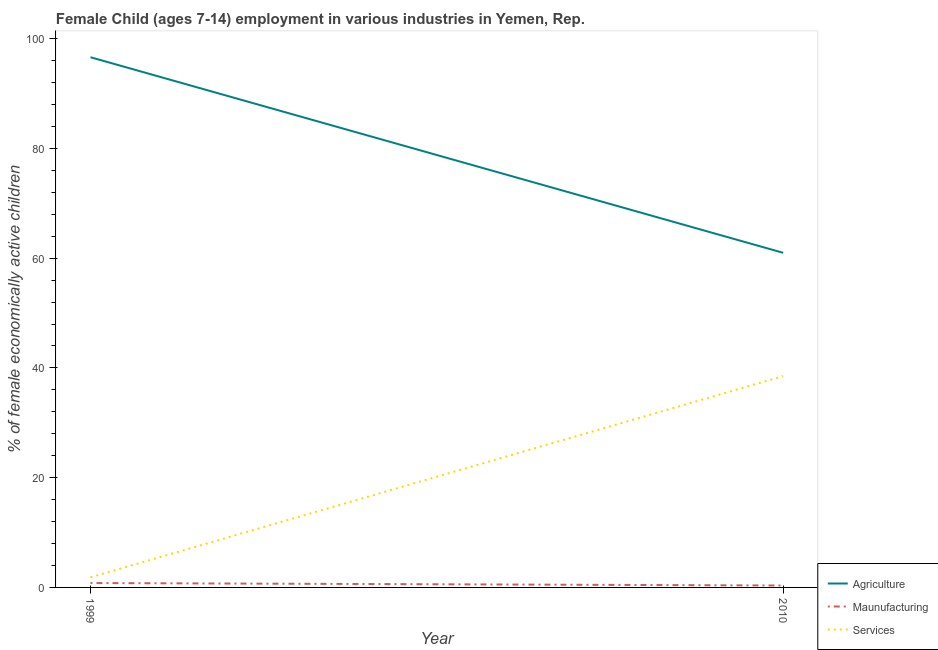How many different coloured lines are there?
Give a very brief answer. 3. What is the percentage of economically active children in agriculture in 2010?
Your answer should be compact. 60.98. Across all years, what is the maximum percentage of economically active children in services?
Provide a short and direct response. 38.51. Across all years, what is the minimum percentage of economically active children in services?
Offer a very short reply. 1.84. In which year was the percentage of economically active children in services maximum?
Offer a terse response. 2010. In which year was the percentage of economically active children in manufacturing minimum?
Your response must be concise. 2010. What is the total percentage of economically active children in services in the graph?
Ensure brevity in your answer.  40.35. What is the difference between the percentage of economically active children in manufacturing in 1999 and that in 2010?
Provide a succinct answer. 0.45. What is the difference between the percentage of economically active children in manufacturing in 2010 and the percentage of economically active children in services in 1999?
Provide a succinct answer. -1.49. What is the average percentage of economically active children in agriculture per year?
Provide a short and direct response. 78.8. In the year 2010, what is the difference between the percentage of economically active children in agriculture and percentage of economically active children in services?
Ensure brevity in your answer.  22.47. What is the ratio of the percentage of economically active children in services in 1999 to that in 2010?
Offer a terse response. 0.05. Is the percentage of economically active children in manufacturing in 1999 less than that in 2010?
Offer a very short reply. No. Is it the case that in every year, the sum of the percentage of economically active children in agriculture and percentage of economically active children in manufacturing is greater than the percentage of economically active children in services?
Keep it short and to the point. Yes. Is the percentage of economically active children in agriculture strictly greater than the percentage of economically active children in manufacturing over the years?
Your answer should be very brief. Yes. How many lines are there?
Your answer should be very brief. 3. What is the difference between two consecutive major ticks on the Y-axis?
Offer a very short reply. 20. Does the graph contain any zero values?
Make the answer very short. No. Where does the legend appear in the graph?
Keep it short and to the point. Bottom right. What is the title of the graph?
Give a very brief answer. Female Child (ages 7-14) employment in various industries in Yemen, Rep. What is the label or title of the Y-axis?
Your answer should be compact. % of female economically active children. What is the % of female economically active children in Agriculture in 1999?
Keep it short and to the point. 96.62. What is the % of female economically active children in Services in 1999?
Your answer should be very brief. 1.84. What is the % of female economically active children in Agriculture in 2010?
Offer a very short reply. 60.98. What is the % of female economically active children of Maunufacturing in 2010?
Offer a terse response. 0.35. What is the % of female economically active children of Services in 2010?
Provide a succinct answer. 38.51. Across all years, what is the maximum % of female economically active children in Agriculture?
Make the answer very short. 96.62. Across all years, what is the maximum % of female economically active children in Maunufacturing?
Provide a succinct answer. 0.8. Across all years, what is the maximum % of female economically active children of Services?
Make the answer very short. 38.51. Across all years, what is the minimum % of female economically active children of Agriculture?
Ensure brevity in your answer.  60.98. Across all years, what is the minimum % of female economically active children of Maunufacturing?
Make the answer very short. 0.35. Across all years, what is the minimum % of female economically active children of Services?
Provide a short and direct response. 1.84. What is the total % of female economically active children of Agriculture in the graph?
Offer a terse response. 157.6. What is the total % of female economically active children in Maunufacturing in the graph?
Offer a terse response. 1.15. What is the total % of female economically active children of Services in the graph?
Your answer should be very brief. 40.35. What is the difference between the % of female economically active children in Agriculture in 1999 and that in 2010?
Give a very brief answer. 35.64. What is the difference between the % of female economically active children of Maunufacturing in 1999 and that in 2010?
Keep it short and to the point. 0.45. What is the difference between the % of female economically active children in Services in 1999 and that in 2010?
Make the answer very short. -36.67. What is the difference between the % of female economically active children of Agriculture in 1999 and the % of female economically active children of Maunufacturing in 2010?
Your answer should be very brief. 96.27. What is the difference between the % of female economically active children in Agriculture in 1999 and the % of female economically active children in Services in 2010?
Your answer should be very brief. 58.11. What is the difference between the % of female economically active children in Maunufacturing in 1999 and the % of female economically active children in Services in 2010?
Provide a short and direct response. -37.71. What is the average % of female economically active children of Agriculture per year?
Your response must be concise. 78.8. What is the average % of female economically active children in Maunufacturing per year?
Keep it short and to the point. 0.57. What is the average % of female economically active children of Services per year?
Offer a terse response. 20.18. In the year 1999, what is the difference between the % of female economically active children in Agriculture and % of female economically active children in Maunufacturing?
Ensure brevity in your answer.  95.82. In the year 1999, what is the difference between the % of female economically active children of Agriculture and % of female economically active children of Services?
Keep it short and to the point. 94.78. In the year 1999, what is the difference between the % of female economically active children in Maunufacturing and % of female economically active children in Services?
Provide a succinct answer. -1.04. In the year 2010, what is the difference between the % of female economically active children in Agriculture and % of female economically active children in Maunufacturing?
Your answer should be compact. 60.63. In the year 2010, what is the difference between the % of female economically active children of Agriculture and % of female economically active children of Services?
Offer a terse response. 22.47. In the year 2010, what is the difference between the % of female economically active children of Maunufacturing and % of female economically active children of Services?
Offer a terse response. -38.16. What is the ratio of the % of female economically active children in Agriculture in 1999 to that in 2010?
Provide a succinct answer. 1.58. What is the ratio of the % of female economically active children in Maunufacturing in 1999 to that in 2010?
Provide a short and direct response. 2.29. What is the ratio of the % of female economically active children in Services in 1999 to that in 2010?
Offer a terse response. 0.05. What is the difference between the highest and the second highest % of female economically active children in Agriculture?
Ensure brevity in your answer.  35.64. What is the difference between the highest and the second highest % of female economically active children of Maunufacturing?
Keep it short and to the point. 0.45. What is the difference between the highest and the second highest % of female economically active children of Services?
Provide a short and direct response. 36.67. What is the difference between the highest and the lowest % of female economically active children in Agriculture?
Make the answer very short. 35.64. What is the difference between the highest and the lowest % of female economically active children of Maunufacturing?
Keep it short and to the point. 0.45. What is the difference between the highest and the lowest % of female economically active children of Services?
Your response must be concise. 36.67. 